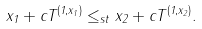<formula> <loc_0><loc_0><loc_500><loc_500>x _ { 1 } + c T ^ { ( 1 , x _ { 1 } ) } \leq _ { s t } x _ { 2 } + c T ^ { ( 1 , x _ { 2 } ) } .</formula> 